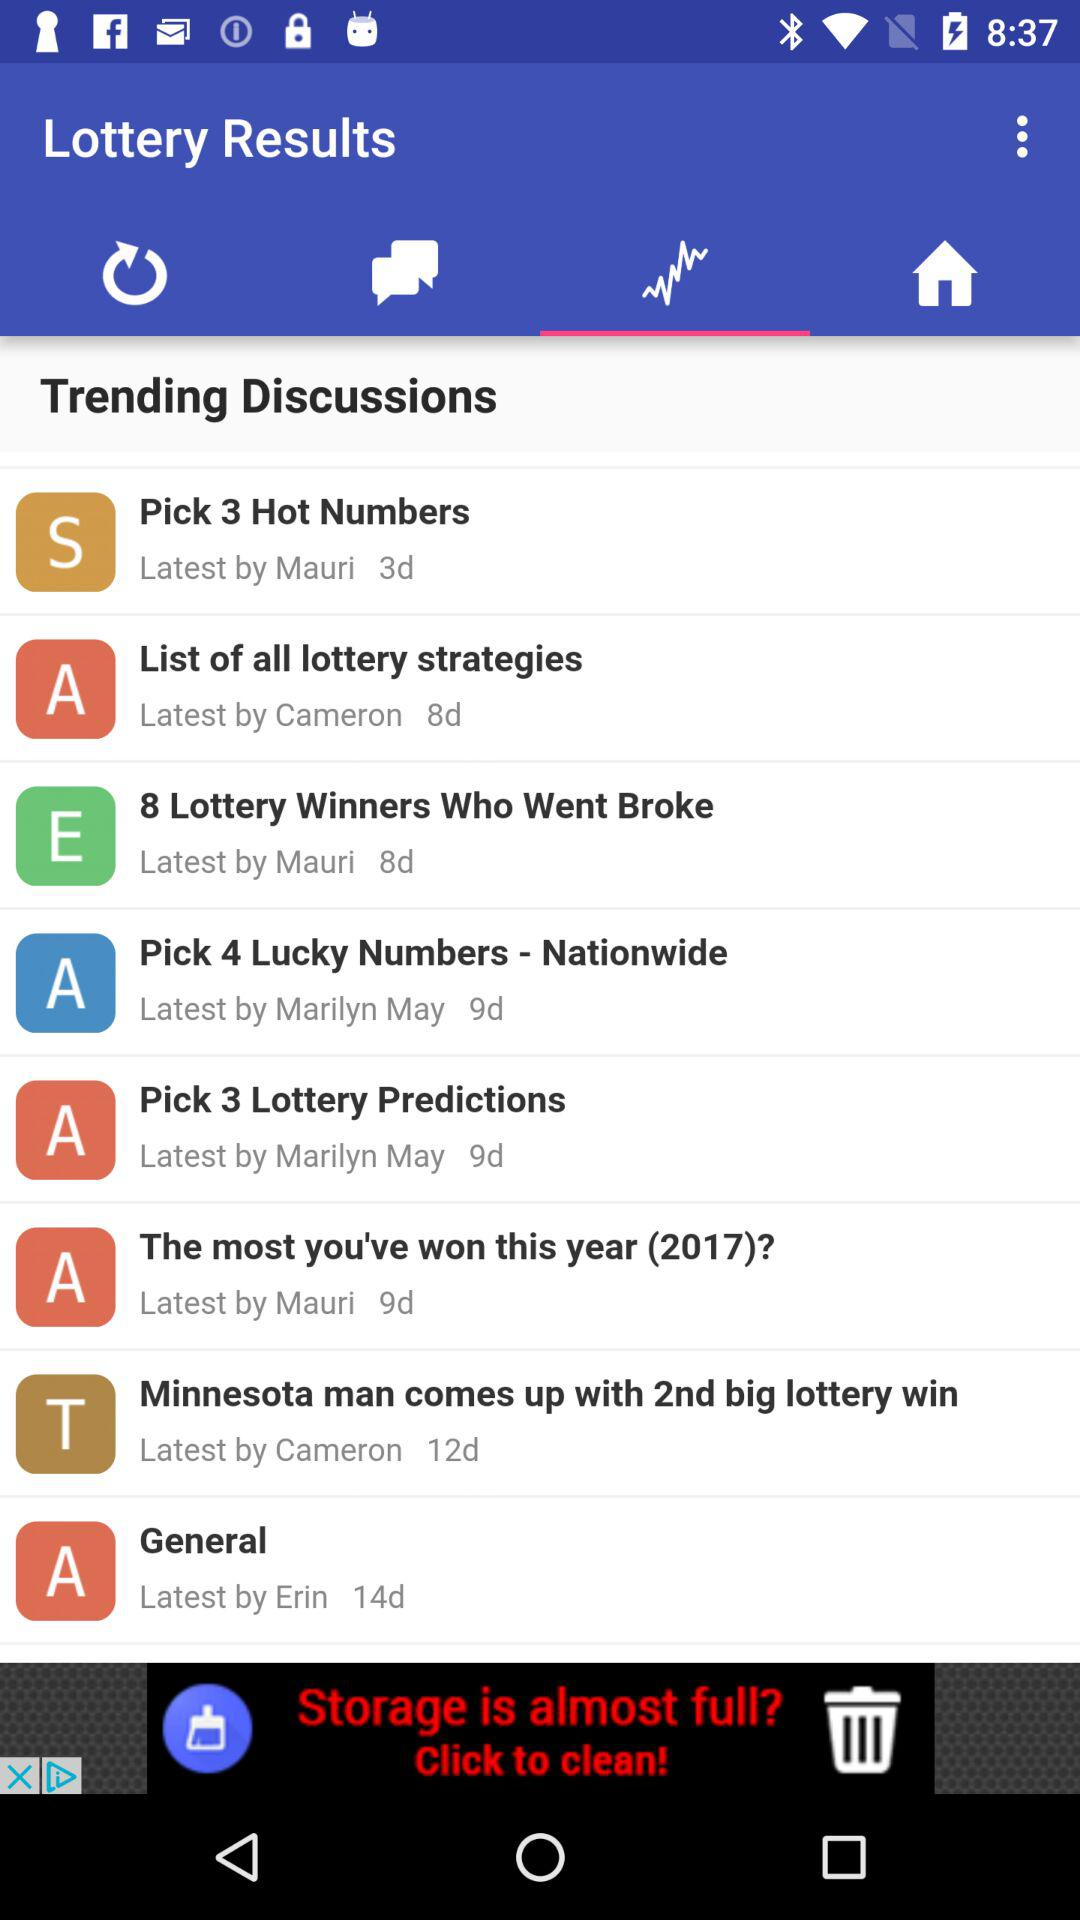How many days ago was the discussion "General" done by Erin? The discussion "General" was done by Erin 14 days ago. 